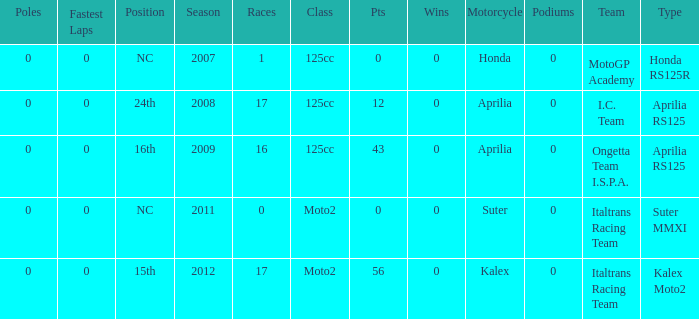How many fastest laps did I.C. Team have? 1.0. Could you help me parse every detail presented in this table? {'header': ['Poles', 'Fastest Laps', 'Position', 'Season', 'Races', 'Class', 'Pts', 'Wins', 'Motorcycle', 'Podiums', 'Team', 'Type'], 'rows': [['0', '0', 'NC', '2007', '1', '125cc', '0', '0', 'Honda', '0', 'MotoGP Academy', 'Honda RS125R'], ['0', '0', '24th', '2008', '17', '125cc', '12', '0', 'Aprilia', '0', 'I.C. Team', 'Aprilia RS125'], ['0', '0', '16th', '2009', '16', '125cc', '43', '0', 'Aprilia', '0', 'Ongetta Team I.S.P.A.', 'Aprilia RS125'], ['0', '0', 'NC', '2011', '0', 'Moto2', '0', '0', 'Suter', '0', 'Italtrans Racing Team', 'Suter MMXI'], ['0', '0', '15th', '2012', '17', 'Moto2', '56', '0', 'Kalex', '0', 'Italtrans Racing Team', 'Kalex Moto2']]} 